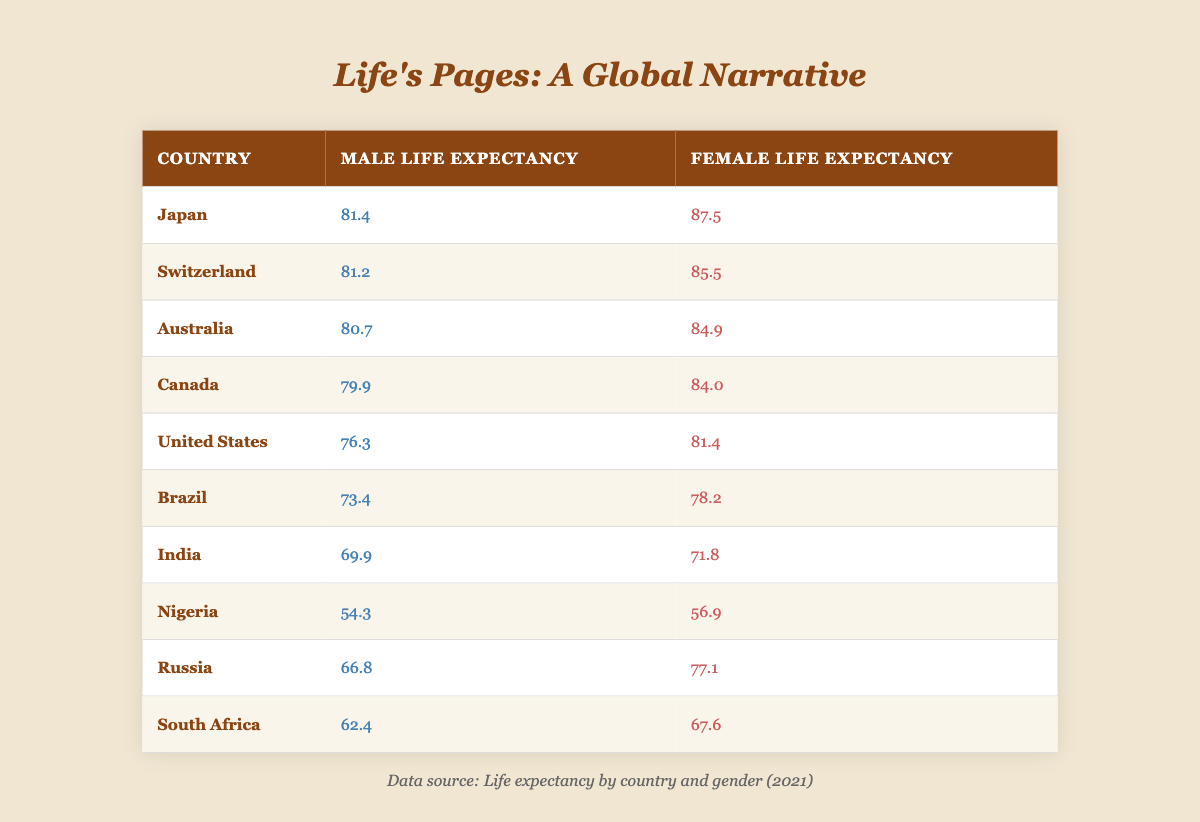What is the life expectancy for females in Japan? The table lists Japan under the country column and shows the female life expectancy as 87.5.
Answer: 87.5 Which country has the highest male life expectancy? By looking at the male life expectancy column, Japan has the highest value of 81.4 compared to the other countries listed.
Answer: Japan What is the difference in life expectancy between males and females in Canada? For Canada, the male life expectancy is 79.9 and the female life expectancy is 84.0. The difference is calculated as 84.0 - 79.9 = 4.1.
Answer: 4.1 True or False: Brazil has a higher male life expectancy than South Africa. Brazil's male life expectancy is 73.4, while South Africa's is 62.4. Since 73.4 is greater than 62.4, the statement is true.
Answer: True What is the average female life expectancy of the countries listed? To find the average, sum the female life expectancies (87.5 + 85.5 + 84.9 + 84.0 + 81.4 + 78.2 + 71.8 + 56.9 + 77.1 + 67.6 =  857.0) and divide by 10 (the number of countries), giving an average of 857.0 / 10 = 85.7.
Answer: 85.7 Which country has the largest gap in life expectancy between genders? To find this, calculate the difference between male and female life expectancy for each country. The largest gap is in Russia, where the difference is 77.1 - 66.8 = 10.3.
Answer: Russia Does Nigeria have a higher female life expectancy than India? Nigeria's female life expectancy is 56.9 while India's is 71.8. Since 56.9 is less than 71.8, the statement is false.
Answer: False What is the ratio of male to female life expectancy in the United States? For the U.S., male life expectancy is 76.3 and female is 81.4. The ratio is calculated as 76.3:81.4, which simplifies to approximately 0.93:1.
Answer: 0.93:1 